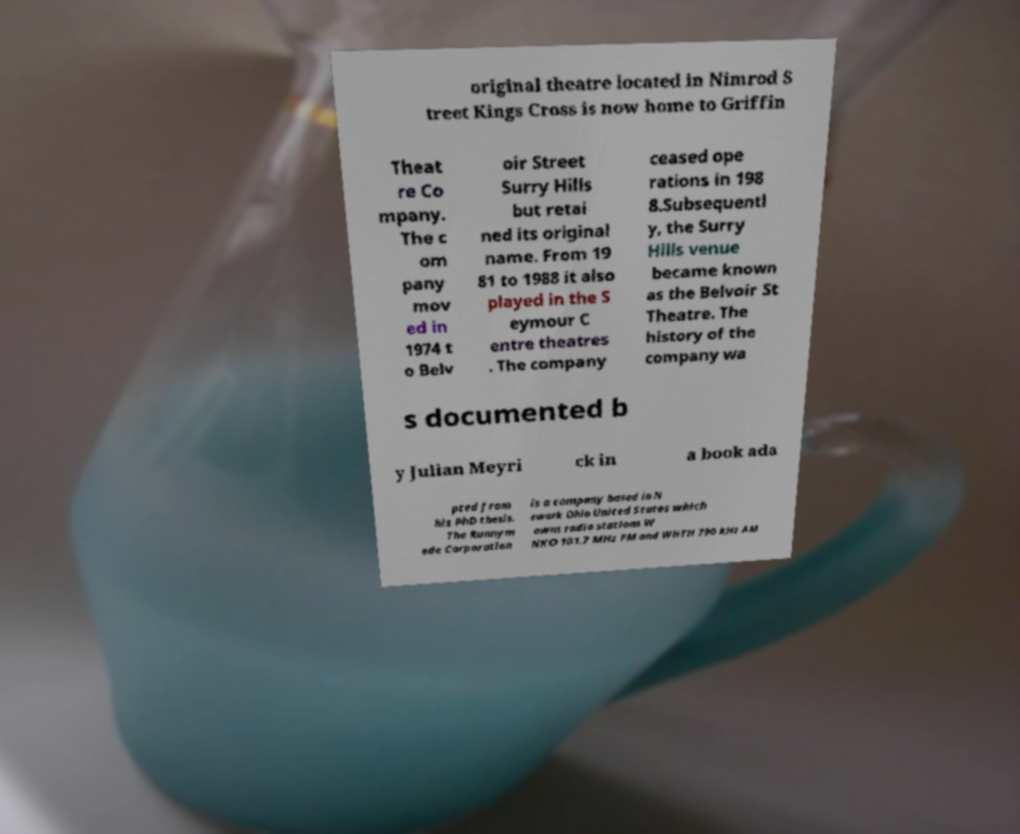I need the written content from this picture converted into text. Can you do that? original theatre located in Nimrod S treet Kings Cross is now home to Griffin Theat re Co mpany. The c om pany mov ed in 1974 t o Belv oir Street Surry Hills but retai ned its original name. From 19 81 to 1988 it also played in the S eymour C entre theatres . The company ceased ope rations in 198 8.Subsequentl y, the Surry Hills venue became known as the Belvoir St Theatre. The history of the company wa s documented b y Julian Meyri ck in a book ada pted from his PhD thesis. The Runnym ede Corporation is a company based in N ewark Ohio United States which owns radio stations W NKO 101.7 MHz FM and WHTH 790 kHz AM 